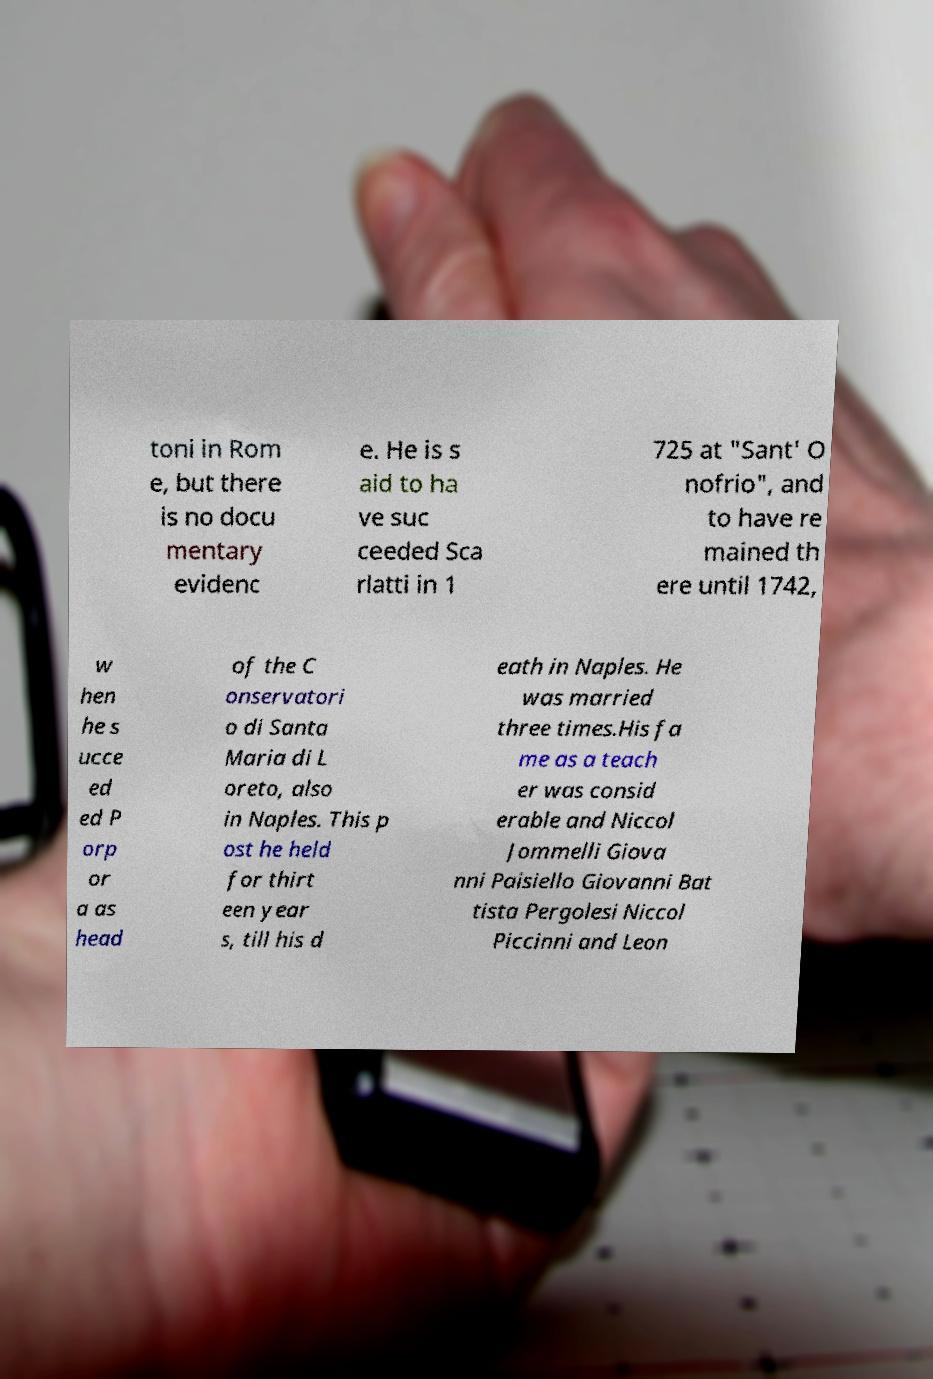Could you assist in decoding the text presented in this image and type it out clearly? toni in Rom e, but there is no docu mentary evidenc e. He is s aid to ha ve suc ceeded Sca rlatti in 1 725 at "Sant' O nofrio", and to have re mained th ere until 1742, w hen he s ucce ed ed P orp or a as head of the C onservatori o di Santa Maria di L oreto, also in Naples. This p ost he held for thirt een year s, till his d eath in Naples. He was married three times.His fa me as a teach er was consid erable and Niccol Jommelli Giova nni Paisiello Giovanni Bat tista Pergolesi Niccol Piccinni and Leon 